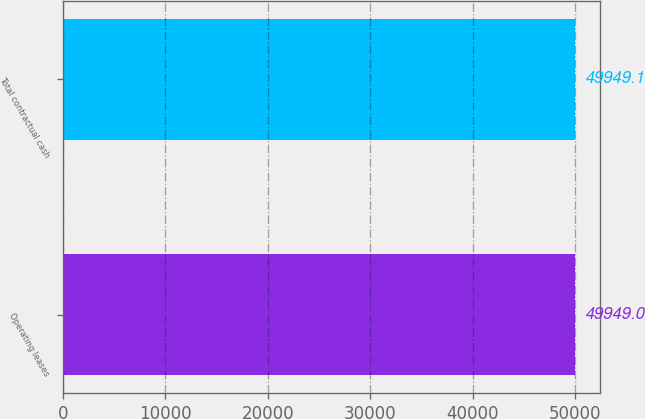Convert chart. <chart><loc_0><loc_0><loc_500><loc_500><bar_chart><fcel>Operating leases<fcel>Total contractual cash<nl><fcel>49949<fcel>49949.1<nl></chart> 